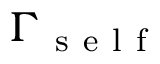Convert formula to latex. <formula><loc_0><loc_0><loc_500><loc_500>\Gamma _ { s e l f }</formula> 